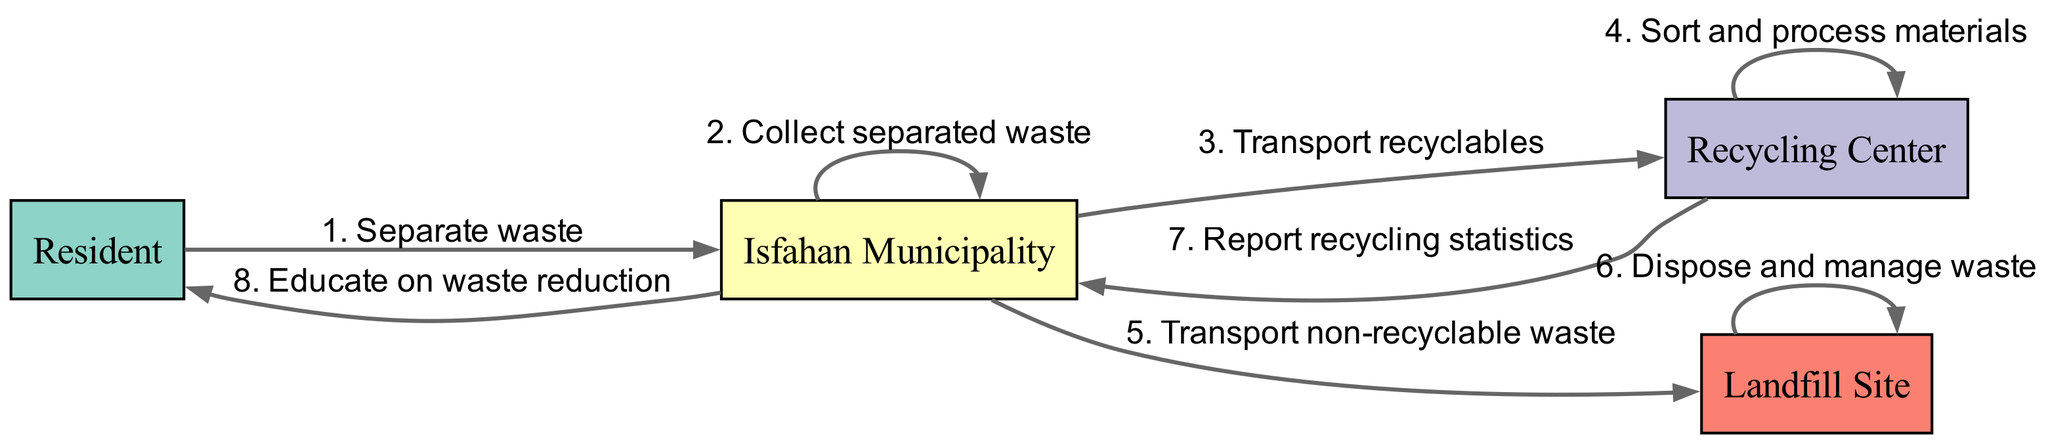What is the total number of actors in the diagram? The diagram lists four actors: Resident, Isfahan Municipality, Recycling Center, and Landfill Site. Therefore, by simply counting each one, we find that there are four distinct actors.
Answer: 4 What action takes place between the Isfahan Municipality and the Recycling Center? According to the sequence, after the Isfahan Municipality collects separated waste, the next action is to transport recyclables to the Recycling Center. This shows a direct relationship involving the movement of materials.
Answer: Transport recyclables Which actor educates residents on waste reduction? From the sequence diagram, the Isfahan Municipality is responsible for educating residents on waste reduction. It is the only action in the sequence where this educational interaction occurs.
Answer: Isfahan Municipality What action is performed by the Recycling Center after receiving materials? The Recycling Center is tasked with sorting and processing materials after they are transported to it. This is indicated as a key action that follows the transport of recyclables.
Answer: Sort and process materials How many transport actions are highlighted in the diagram? There are two transport actions highlighted: one for "Transport recyclables" (to Recycling Center) and another for "Transport non-recyclable waste" (to Landfill Site). By examining the sequence step-by-step, both transport actions can be counted.
Answer: 2 What does the Recycling Center report back to the Isfahan Municipality? The Recycling Center reports recycling statistics back to the Isfahan Municipality as part of the feedback mechanism involving waste management and recycling processes. This is specifically mentioned as an output of the Recycling Center.
Answer: Report recycling statistics What happens after the landfill site receives non-recyclable waste? Once the landfill site receives non-recyclable waste, it is responsible for disposing of and managing that waste. This is a crucial action that describes the landfill's role in the overall process.
Answer: Dispose and manage waste What is the first action taken by the Resident in the waste management process? The very first action taken by the Resident as indicated in the sequence is to separate waste. This initiates the entire waste management and recycling process in Isfahan.
Answer: Separate waste 